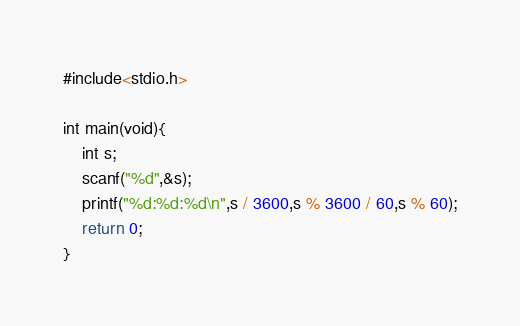<code> <loc_0><loc_0><loc_500><loc_500><_Scala_>#include<stdio.h>

int main(void){
    int s;
    scanf("%d",&s);
    printf("%d:%d:%d\n",s / 3600,s % 3600 / 60,s % 60);
    return 0;
}</code> 